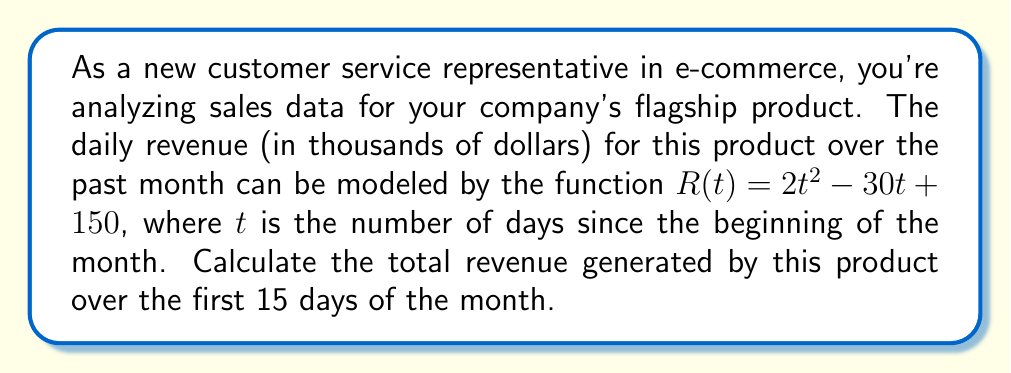Give your solution to this math problem. To solve this problem, we need to use definite integration. The total revenue over a period of time is the area under the revenue curve, which can be calculated using the following steps:

1. Set up the definite integral:
   $$\int_{0}^{15} R(t) dt = \int_{0}^{15} (2t^2 - 30t + 150) dt$$

2. Integrate the function:
   $$\int (2t^2 - 30t + 150) dt = \frac{2t^3}{3} - 15t^2 + 150t + C$$

3. Apply the fundamental theorem of calculus:
   $$\left[\frac{2t^3}{3} - 15t^2 + 150t\right]_{0}^{15}$$

4. Evaluate the integral:
   $$\left(\frac{2(15)^3}{3} - 15(15)^2 + 150(15)\right) - \left(\frac{2(0)^3}{3} - 15(0)^2 + 150(0)\right)$$
   
   $$= (2250 - 3375 + 2250) - (0 - 0 + 0)$$
   
   $$= 1125$$

5. Interpret the result:
   The total revenue over the first 15 days is 1,125 thousand dollars, or $1,125,000.
Answer: $1,125,000 